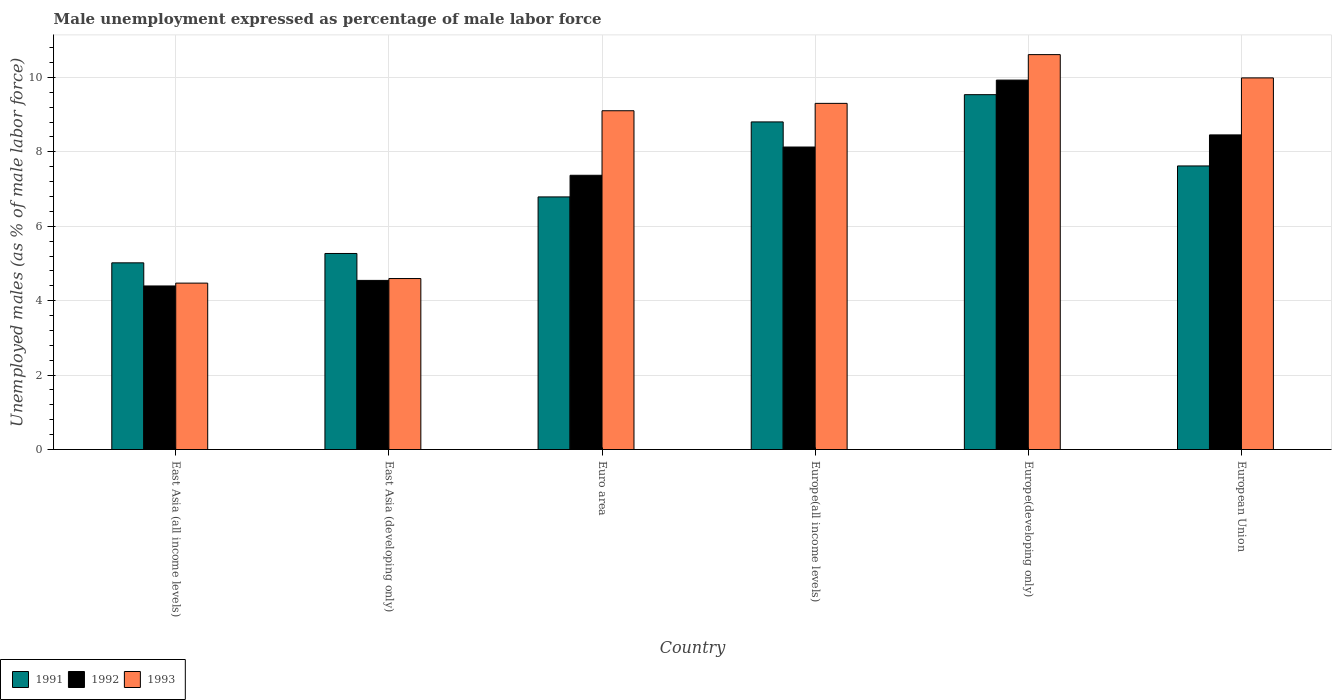How many groups of bars are there?
Your answer should be very brief. 6. Are the number of bars per tick equal to the number of legend labels?
Ensure brevity in your answer.  Yes. What is the label of the 2nd group of bars from the left?
Make the answer very short. East Asia (developing only). In how many cases, is the number of bars for a given country not equal to the number of legend labels?
Your response must be concise. 0. What is the unemployment in males in in 1991 in East Asia (all income levels)?
Your answer should be very brief. 5.02. Across all countries, what is the maximum unemployment in males in in 1991?
Ensure brevity in your answer.  9.54. Across all countries, what is the minimum unemployment in males in in 1993?
Ensure brevity in your answer.  4.47. In which country was the unemployment in males in in 1993 maximum?
Your answer should be compact. Europe(developing only). In which country was the unemployment in males in in 1991 minimum?
Your response must be concise. East Asia (all income levels). What is the total unemployment in males in in 1992 in the graph?
Keep it short and to the point. 42.82. What is the difference between the unemployment in males in in 1992 in East Asia (all income levels) and that in Euro area?
Your answer should be very brief. -2.97. What is the difference between the unemployment in males in in 1991 in East Asia (all income levels) and the unemployment in males in in 1993 in Europe(all income levels)?
Give a very brief answer. -4.29. What is the average unemployment in males in in 1992 per country?
Give a very brief answer. 7.14. What is the difference between the unemployment in males in of/in 1991 and unemployment in males in of/in 1992 in East Asia (all income levels)?
Give a very brief answer. 0.62. In how many countries, is the unemployment in males in in 1993 greater than 2.8 %?
Give a very brief answer. 6. What is the ratio of the unemployment in males in in 1991 in East Asia (developing only) to that in Europe(developing only)?
Your answer should be compact. 0.55. Is the unemployment in males in in 1991 in Europe(all income levels) less than that in European Union?
Offer a terse response. No. What is the difference between the highest and the second highest unemployment in males in in 1992?
Your response must be concise. -1.47. What is the difference between the highest and the lowest unemployment in males in in 1992?
Ensure brevity in your answer.  5.53. In how many countries, is the unemployment in males in in 1992 greater than the average unemployment in males in in 1992 taken over all countries?
Ensure brevity in your answer.  4. Is the sum of the unemployment in males in in 1991 in Euro area and Europe(all income levels) greater than the maximum unemployment in males in in 1992 across all countries?
Ensure brevity in your answer.  Yes. What does the 1st bar from the right in Europe(developing only) represents?
Your response must be concise. 1993. How many bars are there?
Your answer should be compact. 18. Are all the bars in the graph horizontal?
Your response must be concise. No. Are the values on the major ticks of Y-axis written in scientific E-notation?
Make the answer very short. No. Does the graph contain any zero values?
Ensure brevity in your answer.  No. Does the graph contain grids?
Offer a very short reply. Yes. What is the title of the graph?
Your response must be concise. Male unemployment expressed as percentage of male labor force. Does "1969" appear as one of the legend labels in the graph?
Provide a short and direct response. No. What is the label or title of the X-axis?
Keep it short and to the point. Country. What is the label or title of the Y-axis?
Ensure brevity in your answer.  Unemployed males (as % of male labor force). What is the Unemployed males (as % of male labor force) in 1991 in East Asia (all income levels)?
Offer a very short reply. 5.02. What is the Unemployed males (as % of male labor force) of 1992 in East Asia (all income levels)?
Provide a short and direct response. 4.4. What is the Unemployed males (as % of male labor force) in 1993 in East Asia (all income levels)?
Keep it short and to the point. 4.47. What is the Unemployed males (as % of male labor force) of 1991 in East Asia (developing only)?
Ensure brevity in your answer.  5.27. What is the Unemployed males (as % of male labor force) of 1992 in East Asia (developing only)?
Your answer should be compact. 4.55. What is the Unemployed males (as % of male labor force) in 1993 in East Asia (developing only)?
Provide a short and direct response. 4.6. What is the Unemployed males (as % of male labor force) in 1991 in Euro area?
Your answer should be compact. 6.79. What is the Unemployed males (as % of male labor force) of 1992 in Euro area?
Ensure brevity in your answer.  7.37. What is the Unemployed males (as % of male labor force) in 1993 in Euro area?
Keep it short and to the point. 9.1. What is the Unemployed males (as % of male labor force) in 1991 in Europe(all income levels)?
Provide a succinct answer. 8.8. What is the Unemployed males (as % of male labor force) in 1992 in Europe(all income levels)?
Make the answer very short. 8.13. What is the Unemployed males (as % of male labor force) of 1993 in Europe(all income levels)?
Keep it short and to the point. 9.3. What is the Unemployed males (as % of male labor force) in 1991 in Europe(developing only)?
Your response must be concise. 9.54. What is the Unemployed males (as % of male labor force) in 1992 in Europe(developing only)?
Your answer should be very brief. 9.93. What is the Unemployed males (as % of male labor force) in 1993 in Europe(developing only)?
Offer a terse response. 10.61. What is the Unemployed males (as % of male labor force) of 1991 in European Union?
Give a very brief answer. 7.62. What is the Unemployed males (as % of male labor force) of 1992 in European Union?
Provide a short and direct response. 8.46. What is the Unemployed males (as % of male labor force) in 1993 in European Union?
Your answer should be very brief. 9.99. Across all countries, what is the maximum Unemployed males (as % of male labor force) in 1991?
Your answer should be very brief. 9.54. Across all countries, what is the maximum Unemployed males (as % of male labor force) of 1992?
Keep it short and to the point. 9.93. Across all countries, what is the maximum Unemployed males (as % of male labor force) in 1993?
Keep it short and to the point. 10.61. Across all countries, what is the minimum Unemployed males (as % of male labor force) of 1991?
Offer a terse response. 5.02. Across all countries, what is the minimum Unemployed males (as % of male labor force) of 1992?
Offer a terse response. 4.4. Across all countries, what is the minimum Unemployed males (as % of male labor force) in 1993?
Provide a succinct answer. 4.47. What is the total Unemployed males (as % of male labor force) in 1991 in the graph?
Your answer should be compact. 43.04. What is the total Unemployed males (as % of male labor force) of 1992 in the graph?
Your answer should be very brief. 42.82. What is the total Unemployed males (as % of male labor force) in 1993 in the graph?
Ensure brevity in your answer.  48.07. What is the difference between the Unemployed males (as % of male labor force) in 1991 in East Asia (all income levels) and that in East Asia (developing only)?
Offer a terse response. -0.25. What is the difference between the Unemployed males (as % of male labor force) of 1992 in East Asia (all income levels) and that in East Asia (developing only)?
Ensure brevity in your answer.  -0.15. What is the difference between the Unemployed males (as % of male labor force) in 1993 in East Asia (all income levels) and that in East Asia (developing only)?
Provide a short and direct response. -0.12. What is the difference between the Unemployed males (as % of male labor force) of 1991 in East Asia (all income levels) and that in Euro area?
Provide a succinct answer. -1.77. What is the difference between the Unemployed males (as % of male labor force) of 1992 in East Asia (all income levels) and that in Euro area?
Ensure brevity in your answer.  -2.97. What is the difference between the Unemployed males (as % of male labor force) in 1993 in East Asia (all income levels) and that in Euro area?
Make the answer very short. -4.63. What is the difference between the Unemployed males (as % of male labor force) of 1991 in East Asia (all income levels) and that in Europe(all income levels)?
Provide a succinct answer. -3.79. What is the difference between the Unemployed males (as % of male labor force) of 1992 in East Asia (all income levels) and that in Europe(all income levels)?
Ensure brevity in your answer.  -3.73. What is the difference between the Unemployed males (as % of male labor force) of 1993 in East Asia (all income levels) and that in Europe(all income levels)?
Keep it short and to the point. -4.83. What is the difference between the Unemployed males (as % of male labor force) of 1991 in East Asia (all income levels) and that in Europe(developing only)?
Provide a succinct answer. -4.52. What is the difference between the Unemployed males (as % of male labor force) of 1992 in East Asia (all income levels) and that in Europe(developing only)?
Your answer should be compact. -5.53. What is the difference between the Unemployed males (as % of male labor force) of 1993 in East Asia (all income levels) and that in Europe(developing only)?
Give a very brief answer. -6.14. What is the difference between the Unemployed males (as % of male labor force) of 1991 in East Asia (all income levels) and that in European Union?
Make the answer very short. -2.6. What is the difference between the Unemployed males (as % of male labor force) in 1992 in East Asia (all income levels) and that in European Union?
Ensure brevity in your answer.  -4.06. What is the difference between the Unemployed males (as % of male labor force) in 1993 in East Asia (all income levels) and that in European Union?
Offer a very short reply. -5.52. What is the difference between the Unemployed males (as % of male labor force) of 1991 in East Asia (developing only) and that in Euro area?
Provide a short and direct response. -1.52. What is the difference between the Unemployed males (as % of male labor force) in 1992 in East Asia (developing only) and that in Euro area?
Your answer should be very brief. -2.82. What is the difference between the Unemployed males (as % of male labor force) in 1993 in East Asia (developing only) and that in Euro area?
Offer a very short reply. -4.51. What is the difference between the Unemployed males (as % of male labor force) in 1991 in East Asia (developing only) and that in Europe(all income levels)?
Offer a terse response. -3.54. What is the difference between the Unemployed males (as % of male labor force) of 1992 in East Asia (developing only) and that in Europe(all income levels)?
Make the answer very short. -3.58. What is the difference between the Unemployed males (as % of male labor force) of 1993 in East Asia (developing only) and that in Europe(all income levels)?
Give a very brief answer. -4.71. What is the difference between the Unemployed males (as % of male labor force) of 1991 in East Asia (developing only) and that in Europe(developing only)?
Offer a very short reply. -4.27. What is the difference between the Unemployed males (as % of male labor force) of 1992 in East Asia (developing only) and that in Europe(developing only)?
Offer a very short reply. -5.38. What is the difference between the Unemployed males (as % of male labor force) of 1993 in East Asia (developing only) and that in Europe(developing only)?
Your answer should be very brief. -6.02. What is the difference between the Unemployed males (as % of male labor force) of 1991 in East Asia (developing only) and that in European Union?
Your answer should be compact. -2.35. What is the difference between the Unemployed males (as % of male labor force) in 1992 in East Asia (developing only) and that in European Union?
Provide a succinct answer. -3.91. What is the difference between the Unemployed males (as % of male labor force) of 1993 in East Asia (developing only) and that in European Union?
Ensure brevity in your answer.  -5.39. What is the difference between the Unemployed males (as % of male labor force) of 1991 in Euro area and that in Europe(all income levels)?
Offer a terse response. -2.02. What is the difference between the Unemployed males (as % of male labor force) of 1992 in Euro area and that in Europe(all income levels)?
Make the answer very short. -0.76. What is the difference between the Unemployed males (as % of male labor force) in 1993 in Euro area and that in Europe(all income levels)?
Keep it short and to the point. -0.2. What is the difference between the Unemployed males (as % of male labor force) of 1991 in Euro area and that in Europe(developing only)?
Your answer should be very brief. -2.75. What is the difference between the Unemployed males (as % of male labor force) of 1992 in Euro area and that in Europe(developing only)?
Give a very brief answer. -2.56. What is the difference between the Unemployed males (as % of male labor force) of 1993 in Euro area and that in Europe(developing only)?
Offer a terse response. -1.51. What is the difference between the Unemployed males (as % of male labor force) of 1991 in Euro area and that in European Union?
Make the answer very short. -0.83. What is the difference between the Unemployed males (as % of male labor force) in 1992 in Euro area and that in European Union?
Your answer should be compact. -1.09. What is the difference between the Unemployed males (as % of male labor force) of 1993 in Euro area and that in European Union?
Your answer should be very brief. -0.88. What is the difference between the Unemployed males (as % of male labor force) of 1991 in Europe(all income levels) and that in Europe(developing only)?
Your answer should be compact. -0.73. What is the difference between the Unemployed males (as % of male labor force) in 1992 in Europe(all income levels) and that in Europe(developing only)?
Ensure brevity in your answer.  -1.8. What is the difference between the Unemployed males (as % of male labor force) of 1993 in Europe(all income levels) and that in Europe(developing only)?
Offer a very short reply. -1.31. What is the difference between the Unemployed males (as % of male labor force) in 1991 in Europe(all income levels) and that in European Union?
Provide a short and direct response. 1.18. What is the difference between the Unemployed males (as % of male labor force) of 1992 in Europe(all income levels) and that in European Union?
Offer a very short reply. -0.33. What is the difference between the Unemployed males (as % of male labor force) in 1993 in Europe(all income levels) and that in European Union?
Offer a very short reply. -0.68. What is the difference between the Unemployed males (as % of male labor force) of 1991 in Europe(developing only) and that in European Union?
Keep it short and to the point. 1.92. What is the difference between the Unemployed males (as % of male labor force) of 1992 in Europe(developing only) and that in European Union?
Ensure brevity in your answer.  1.47. What is the difference between the Unemployed males (as % of male labor force) in 1993 in Europe(developing only) and that in European Union?
Make the answer very short. 0.63. What is the difference between the Unemployed males (as % of male labor force) in 1991 in East Asia (all income levels) and the Unemployed males (as % of male labor force) in 1992 in East Asia (developing only)?
Your answer should be very brief. 0.47. What is the difference between the Unemployed males (as % of male labor force) of 1991 in East Asia (all income levels) and the Unemployed males (as % of male labor force) of 1993 in East Asia (developing only)?
Your answer should be compact. 0.42. What is the difference between the Unemployed males (as % of male labor force) of 1992 in East Asia (all income levels) and the Unemployed males (as % of male labor force) of 1993 in East Asia (developing only)?
Keep it short and to the point. -0.2. What is the difference between the Unemployed males (as % of male labor force) in 1991 in East Asia (all income levels) and the Unemployed males (as % of male labor force) in 1992 in Euro area?
Your answer should be compact. -2.35. What is the difference between the Unemployed males (as % of male labor force) in 1991 in East Asia (all income levels) and the Unemployed males (as % of male labor force) in 1993 in Euro area?
Your answer should be compact. -4.09. What is the difference between the Unemployed males (as % of male labor force) of 1992 in East Asia (all income levels) and the Unemployed males (as % of male labor force) of 1993 in Euro area?
Your answer should be compact. -4.71. What is the difference between the Unemployed males (as % of male labor force) of 1991 in East Asia (all income levels) and the Unemployed males (as % of male labor force) of 1992 in Europe(all income levels)?
Keep it short and to the point. -3.11. What is the difference between the Unemployed males (as % of male labor force) of 1991 in East Asia (all income levels) and the Unemployed males (as % of male labor force) of 1993 in Europe(all income levels)?
Keep it short and to the point. -4.29. What is the difference between the Unemployed males (as % of male labor force) in 1992 in East Asia (all income levels) and the Unemployed males (as % of male labor force) in 1993 in Europe(all income levels)?
Give a very brief answer. -4.91. What is the difference between the Unemployed males (as % of male labor force) of 1991 in East Asia (all income levels) and the Unemployed males (as % of male labor force) of 1992 in Europe(developing only)?
Give a very brief answer. -4.91. What is the difference between the Unemployed males (as % of male labor force) of 1991 in East Asia (all income levels) and the Unemployed males (as % of male labor force) of 1993 in Europe(developing only)?
Ensure brevity in your answer.  -5.6. What is the difference between the Unemployed males (as % of male labor force) in 1992 in East Asia (all income levels) and the Unemployed males (as % of male labor force) in 1993 in Europe(developing only)?
Your answer should be very brief. -6.22. What is the difference between the Unemployed males (as % of male labor force) of 1991 in East Asia (all income levels) and the Unemployed males (as % of male labor force) of 1992 in European Union?
Provide a short and direct response. -3.44. What is the difference between the Unemployed males (as % of male labor force) of 1991 in East Asia (all income levels) and the Unemployed males (as % of male labor force) of 1993 in European Union?
Make the answer very short. -4.97. What is the difference between the Unemployed males (as % of male labor force) in 1992 in East Asia (all income levels) and the Unemployed males (as % of male labor force) in 1993 in European Union?
Give a very brief answer. -5.59. What is the difference between the Unemployed males (as % of male labor force) of 1991 in East Asia (developing only) and the Unemployed males (as % of male labor force) of 1992 in Euro area?
Ensure brevity in your answer.  -2.1. What is the difference between the Unemployed males (as % of male labor force) in 1991 in East Asia (developing only) and the Unemployed males (as % of male labor force) in 1993 in Euro area?
Offer a very short reply. -3.84. What is the difference between the Unemployed males (as % of male labor force) of 1992 in East Asia (developing only) and the Unemployed males (as % of male labor force) of 1993 in Euro area?
Your answer should be very brief. -4.56. What is the difference between the Unemployed males (as % of male labor force) in 1991 in East Asia (developing only) and the Unemployed males (as % of male labor force) in 1992 in Europe(all income levels)?
Your answer should be very brief. -2.86. What is the difference between the Unemployed males (as % of male labor force) of 1991 in East Asia (developing only) and the Unemployed males (as % of male labor force) of 1993 in Europe(all income levels)?
Make the answer very short. -4.03. What is the difference between the Unemployed males (as % of male labor force) in 1992 in East Asia (developing only) and the Unemployed males (as % of male labor force) in 1993 in Europe(all income levels)?
Give a very brief answer. -4.76. What is the difference between the Unemployed males (as % of male labor force) in 1991 in East Asia (developing only) and the Unemployed males (as % of male labor force) in 1992 in Europe(developing only)?
Provide a succinct answer. -4.66. What is the difference between the Unemployed males (as % of male labor force) of 1991 in East Asia (developing only) and the Unemployed males (as % of male labor force) of 1993 in Europe(developing only)?
Provide a succinct answer. -5.34. What is the difference between the Unemployed males (as % of male labor force) in 1992 in East Asia (developing only) and the Unemployed males (as % of male labor force) in 1993 in Europe(developing only)?
Your response must be concise. -6.07. What is the difference between the Unemployed males (as % of male labor force) of 1991 in East Asia (developing only) and the Unemployed males (as % of male labor force) of 1992 in European Union?
Ensure brevity in your answer.  -3.19. What is the difference between the Unemployed males (as % of male labor force) of 1991 in East Asia (developing only) and the Unemployed males (as % of male labor force) of 1993 in European Union?
Make the answer very short. -4.72. What is the difference between the Unemployed males (as % of male labor force) of 1992 in East Asia (developing only) and the Unemployed males (as % of male labor force) of 1993 in European Union?
Provide a short and direct response. -5.44. What is the difference between the Unemployed males (as % of male labor force) of 1991 in Euro area and the Unemployed males (as % of male labor force) of 1992 in Europe(all income levels)?
Your answer should be very brief. -1.34. What is the difference between the Unemployed males (as % of male labor force) of 1991 in Euro area and the Unemployed males (as % of male labor force) of 1993 in Europe(all income levels)?
Offer a terse response. -2.51. What is the difference between the Unemployed males (as % of male labor force) of 1992 in Euro area and the Unemployed males (as % of male labor force) of 1993 in Europe(all income levels)?
Offer a terse response. -1.93. What is the difference between the Unemployed males (as % of male labor force) of 1991 in Euro area and the Unemployed males (as % of male labor force) of 1992 in Europe(developing only)?
Your response must be concise. -3.14. What is the difference between the Unemployed males (as % of male labor force) of 1991 in Euro area and the Unemployed males (as % of male labor force) of 1993 in Europe(developing only)?
Keep it short and to the point. -3.82. What is the difference between the Unemployed males (as % of male labor force) in 1992 in Euro area and the Unemployed males (as % of male labor force) in 1993 in Europe(developing only)?
Make the answer very short. -3.24. What is the difference between the Unemployed males (as % of male labor force) of 1991 in Euro area and the Unemployed males (as % of male labor force) of 1992 in European Union?
Ensure brevity in your answer.  -1.67. What is the difference between the Unemployed males (as % of male labor force) in 1991 in Euro area and the Unemployed males (as % of male labor force) in 1993 in European Union?
Ensure brevity in your answer.  -3.2. What is the difference between the Unemployed males (as % of male labor force) in 1992 in Euro area and the Unemployed males (as % of male labor force) in 1993 in European Union?
Ensure brevity in your answer.  -2.62. What is the difference between the Unemployed males (as % of male labor force) in 1991 in Europe(all income levels) and the Unemployed males (as % of male labor force) in 1992 in Europe(developing only)?
Make the answer very short. -1.12. What is the difference between the Unemployed males (as % of male labor force) of 1991 in Europe(all income levels) and the Unemployed males (as % of male labor force) of 1993 in Europe(developing only)?
Your response must be concise. -1.81. What is the difference between the Unemployed males (as % of male labor force) of 1992 in Europe(all income levels) and the Unemployed males (as % of male labor force) of 1993 in Europe(developing only)?
Provide a short and direct response. -2.48. What is the difference between the Unemployed males (as % of male labor force) in 1991 in Europe(all income levels) and the Unemployed males (as % of male labor force) in 1992 in European Union?
Offer a very short reply. 0.35. What is the difference between the Unemployed males (as % of male labor force) of 1991 in Europe(all income levels) and the Unemployed males (as % of male labor force) of 1993 in European Union?
Your answer should be very brief. -1.18. What is the difference between the Unemployed males (as % of male labor force) in 1992 in Europe(all income levels) and the Unemployed males (as % of male labor force) in 1993 in European Union?
Make the answer very short. -1.86. What is the difference between the Unemployed males (as % of male labor force) in 1991 in Europe(developing only) and the Unemployed males (as % of male labor force) in 1992 in European Union?
Make the answer very short. 1.08. What is the difference between the Unemployed males (as % of male labor force) in 1991 in Europe(developing only) and the Unemployed males (as % of male labor force) in 1993 in European Union?
Offer a terse response. -0.45. What is the difference between the Unemployed males (as % of male labor force) in 1992 in Europe(developing only) and the Unemployed males (as % of male labor force) in 1993 in European Union?
Offer a terse response. -0.06. What is the average Unemployed males (as % of male labor force) in 1991 per country?
Your answer should be very brief. 7.17. What is the average Unemployed males (as % of male labor force) in 1992 per country?
Make the answer very short. 7.14. What is the average Unemployed males (as % of male labor force) of 1993 per country?
Your response must be concise. 8.01. What is the difference between the Unemployed males (as % of male labor force) of 1991 and Unemployed males (as % of male labor force) of 1992 in East Asia (all income levels)?
Ensure brevity in your answer.  0.62. What is the difference between the Unemployed males (as % of male labor force) in 1991 and Unemployed males (as % of male labor force) in 1993 in East Asia (all income levels)?
Provide a succinct answer. 0.55. What is the difference between the Unemployed males (as % of male labor force) of 1992 and Unemployed males (as % of male labor force) of 1993 in East Asia (all income levels)?
Keep it short and to the point. -0.08. What is the difference between the Unemployed males (as % of male labor force) in 1991 and Unemployed males (as % of male labor force) in 1992 in East Asia (developing only)?
Keep it short and to the point. 0.72. What is the difference between the Unemployed males (as % of male labor force) of 1991 and Unemployed males (as % of male labor force) of 1993 in East Asia (developing only)?
Provide a short and direct response. 0.67. What is the difference between the Unemployed males (as % of male labor force) of 1992 and Unemployed males (as % of male labor force) of 1993 in East Asia (developing only)?
Your answer should be compact. -0.05. What is the difference between the Unemployed males (as % of male labor force) in 1991 and Unemployed males (as % of male labor force) in 1992 in Euro area?
Offer a very short reply. -0.58. What is the difference between the Unemployed males (as % of male labor force) in 1991 and Unemployed males (as % of male labor force) in 1993 in Euro area?
Keep it short and to the point. -2.32. What is the difference between the Unemployed males (as % of male labor force) of 1992 and Unemployed males (as % of male labor force) of 1993 in Euro area?
Offer a very short reply. -1.73. What is the difference between the Unemployed males (as % of male labor force) of 1991 and Unemployed males (as % of male labor force) of 1992 in Europe(all income levels)?
Your answer should be compact. 0.67. What is the difference between the Unemployed males (as % of male labor force) of 1991 and Unemployed males (as % of male labor force) of 1993 in Europe(all income levels)?
Provide a succinct answer. -0.5. What is the difference between the Unemployed males (as % of male labor force) in 1992 and Unemployed males (as % of male labor force) in 1993 in Europe(all income levels)?
Your answer should be very brief. -1.17. What is the difference between the Unemployed males (as % of male labor force) in 1991 and Unemployed males (as % of male labor force) in 1992 in Europe(developing only)?
Offer a terse response. -0.39. What is the difference between the Unemployed males (as % of male labor force) in 1991 and Unemployed males (as % of male labor force) in 1993 in Europe(developing only)?
Your response must be concise. -1.08. What is the difference between the Unemployed males (as % of male labor force) of 1992 and Unemployed males (as % of male labor force) of 1993 in Europe(developing only)?
Provide a succinct answer. -0.68. What is the difference between the Unemployed males (as % of male labor force) of 1991 and Unemployed males (as % of male labor force) of 1992 in European Union?
Offer a terse response. -0.83. What is the difference between the Unemployed males (as % of male labor force) in 1991 and Unemployed males (as % of male labor force) in 1993 in European Union?
Provide a short and direct response. -2.37. What is the difference between the Unemployed males (as % of male labor force) in 1992 and Unemployed males (as % of male labor force) in 1993 in European Union?
Offer a terse response. -1.53. What is the ratio of the Unemployed males (as % of male labor force) of 1991 in East Asia (all income levels) to that in East Asia (developing only)?
Make the answer very short. 0.95. What is the ratio of the Unemployed males (as % of male labor force) in 1992 in East Asia (all income levels) to that in East Asia (developing only)?
Your answer should be very brief. 0.97. What is the ratio of the Unemployed males (as % of male labor force) of 1993 in East Asia (all income levels) to that in East Asia (developing only)?
Offer a very short reply. 0.97. What is the ratio of the Unemployed males (as % of male labor force) of 1991 in East Asia (all income levels) to that in Euro area?
Provide a succinct answer. 0.74. What is the ratio of the Unemployed males (as % of male labor force) in 1992 in East Asia (all income levels) to that in Euro area?
Provide a short and direct response. 0.6. What is the ratio of the Unemployed males (as % of male labor force) in 1993 in East Asia (all income levels) to that in Euro area?
Provide a succinct answer. 0.49. What is the ratio of the Unemployed males (as % of male labor force) of 1991 in East Asia (all income levels) to that in Europe(all income levels)?
Keep it short and to the point. 0.57. What is the ratio of the Unemployed males (as % of male labor force) in 1992 in East Asia (all income levels) to that in Europe(all income levels)?
Your answer should be very brief. 0.54. What is the ratio of the Unemployed males (as % of male labor force) in 1993 in East Asia (all income levels) to that in Europe(all income levels)?
Provide a short and direct response. 0.48. What is the ratio of the Unemployed males (as % of male labor force) of 1991 in East Asia (all income levels) to that in Europe(developing only)?
Give a very brief answer. 0.53. What is the ratio of the Unemployed males (as % of male labor force) of 1992 in East Asia (all income levels) to that in Europe(developing only)?
Give a very brief answer. 0.44. What is the ratio of the Unemployed males (as % of male labor force) in 1993 in East Asia (all income levels) to that in Europe(developing only)?
Offer a very short reply. 0.42. What is the ratio of the Unemployed males (as % of male labor force) in 1991 in East Asia (all income levels) to that in European Union?
Give a very brief answer. 0.66. What is the ratio of the Unemployed males (as % of male labor force) in 1992 in East Asia (all income levels) to that in European Union?
Give a very brief answer. 0.52. What is the ratio of the Unemployed males (as % of male labor force) in 1993 in East Asia (all income levels) to that in European Union?
Ensure brevity in your answer.  0.45. What is the ratio of the Unemployed males (as % of male labor force) in 1991 in East Asia (developing only) to that in Euro area?
Provide a succinct answer. 0.78. What is the ratio of the Unemployed males (as % of male labor force) of 1992 in East Asia (developing only) to that in Euro area?
Offer a very short reply. 0.62. What is the ratio of the Unemployed males (as % of male labor force) of 1993 in East Asia (developing only) to that in Euro area?
Offer a terse response. 0.5. What is the ratio of the Unemployed males (as % of male labor force) in 1991 in East Asia (developing only) to that in Europe(all income levels)?
Offer a terse response. 0.6. What is the ratio of the Unemployed males (as % of male labor force) of 1992 in East Asia (developing only) to that in Europe(all income levels)?
Your answer should be compact. 0.56. What is the ratio of the Unemployed males (as % of male labor force) in 1993 in East Asia (developing only) to that in Europe(all income levels)?
Make the answer very short. 0.49. What is the ratio of the Unemployed males (as % of male labor force) of 1991 in East Asia (developing only) to that in Europe(developing only)?
Keep it short and to the point. 0.55. What is the ratio of the Unemployed males (as % of male labor force) of 1992 in East Asia (developing only) to that in Europe(developing only)?
Your answer should be compact. 0.46. What is the ratio of the Unemployed males (as % of male labor force) of 1993 in East Asia (developing only) to that in Europe(developing only)?
Make the answer very short. 0.43. What is the ratio of the Unemployed males (as % of male labor force) of 1991 in East Asia (developing only) to that in European Union?
Ensure brevity in your answer.  0.69. What is the ratio of the Unemployed males (as % of male labor force) of 1992 in East Asia (developing only) to that in European Union?
Keep it short and to the point. 0.54. What is the ratio of the Unemployed males (as % of male labor force) of 1993 in East Asia (developing only) to that in European Union?
Give a very brief answer. 0.46. What is the ratio of the Unemployed males (as % of male labor force) of 1991 in Euro area to that in Europe(all income levels)?
Keep it short and to the point. 0.77. What is the ratio of the Unemployed males (as % of male labor force) in 1992 in Euro area to that in Europe(all income levels)?
Offer a terse response. 0.91. What is the ratio of the Unemployed males (as % of male labor force) in 1993 in Euro area to that in Europe(all income levels)?
Your response must be concise. 0.98. What is the ratio of the Unemployed males (as % of male labor force) in 1991 in Euro area to that in Europe(developing only)?
Your answer should be compact. 0.71. What is the ratio of the Unemployed males (as % of male labor force) of 1992 in Euro area to that in Europe(developing only)?
Your answer should be compact. 0.74. What is the ratio of the Unemployed males (as % of male labor force) in 1993 in Euro area to that in Europe(developing only)?
Your answer should be compact. 0.86. What is the ratio of the Unemployed males (as % of male labor force) in 1991 in Euro area to that in European Union?
Keep it short and to the point. 0.89. What is the ratio of the Unemployed males (as % of male labor force) of 1992 in Euro area to that in European Union?
Make the answer very short. 0.87. What is the ratio of the Unemployed males (as % of male labor force) in 1993 in Euro area to that in European Union?
Keep it short and to the point. 0.91. What is the ratio of the Unemployed males (as % of male labor force) in 1991 in Europe(all income levels) to that in Europe(developing only)?
Ensure brevity in your answer.  0.92. What is the ratio of the Unemployed males (as % of male labor force) in 1992 in Europe(all income levels) to that in Europe(developing only)?
Make the answer very short. 0.82. What is the ratio of the Unemployed males (as % of male labor force) in 1993 in Europe(all income levels) to that in Europe(developing only)?
Make the answer very short. 0.88. What is the ratio of the Unemployed males (as % of male labor force) of 1991 in Europe(all income levels) to that in European Union?
Provide a succinct answer. 1.16. What is the ratio of the Unemployed males (as % of male labor force) in 1992 in Europe(all income levels) to that in European Union?
Your response must be concise. 0.96. What is the ratio of the Unemployed males (as % of male labor force) in 1993 in Europe(all income levels) to that in European Union?
Ensure brevity in your answer.  0.93. What is the ratio of the Unemployed males (as % of male labor force) in 1991 in Europe(developing only) to that in European Union?
Your answer should be compact. 1.25. What is the ratio of the Unemployed males (as % of male labor force) in 1992 in Europe(developing only) to that in European Union?
Offer a very short reply. 1.17. What is the ratio of the Unemployed males (as % of male labor force) in 1993 in Europe(developing only) to that in European Union?
Make the answer very short. 1.06. What is the difference between the highest and the second highest Unemployed males (as % of male labor force) in 1991?
Your response must be concise. 0.73. What is the difference between the highest and the second highest Unemployed males (as % of male labor force) in 1992?
Ensure brevity in your answer.  1.47. What is the difference between the highest and the second highest Unemployed males (as % of male labor force) in 1993?
Provide a succinct answer. 0.63. What is the difference between the highest and the lowest Unemployed males (as % of male labor force) in 1991?
Keep it short and to the point. 4.52. What is the difference between the highest and the lowest Unemployed males (as % of male labor force) in 1992?
Provide a succinct answer. 5.53. What is the difference between the highest and the lowest Unemployed males (as % of male labor force) in 1993?
Provide a short and direct response. 6.14. 